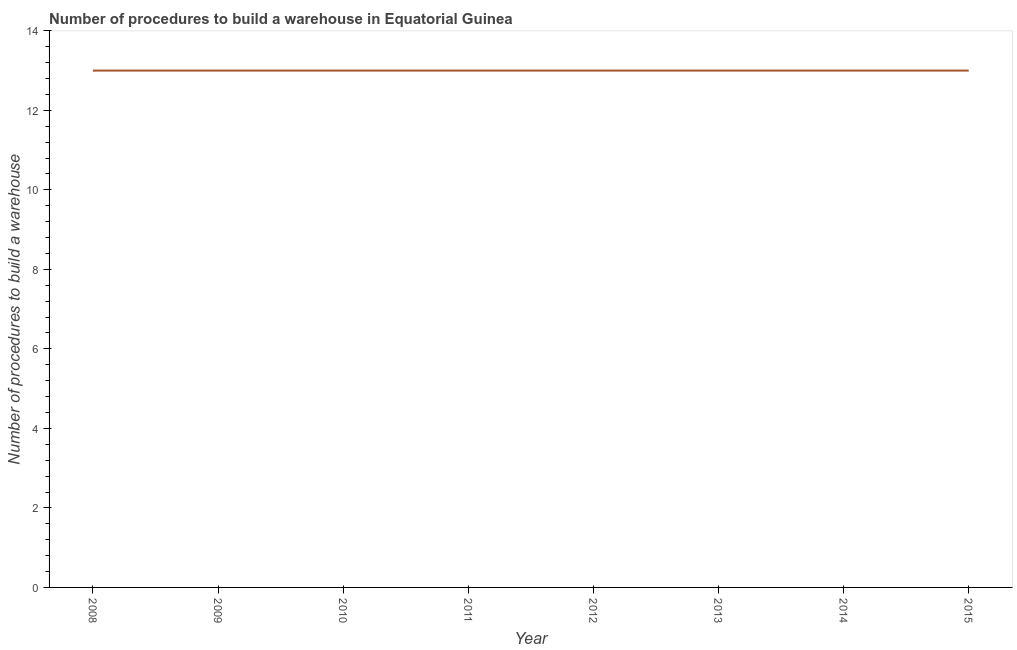What is the number of procedures to build a warehouse in 2010?
Offer a very short reply. 13. Across all years, what is the maximum number of procedures to build a warehouse?
Keep it short and to the point. 13. Across all years, what is the minimum number of procedures to build a warehouse?
Give a very brief answer. 13. What is the sum of the number of procedures to build a warehouse?
Offer a terse response. 104. What is the difference between the number of procedures to build a warehouse in 2010 and 2012?
Keep it short and to the point. 0. What is the average number of procedures to build a warehouse per year?
Offer a very short reply. 13. In how many years, is the number of procedures to build a warehouse greater than 2 ?
Provide a short and direct response. 8. Do a majority of the years between 2015 and 2014 (inclusive) have number of procedures to build a warehouse greater than 1.2000000000000002 ?
Ensure brevity in your answer.  No. Is the number of procedures to build a warehouse in 2010 less than that in 2012?
Offer a terse response. No. Is the difference between the number of procedures to build a warehouse in 2013 and 2015 greater than the difference between any two years?
Keep it short and to the point. Yes. Does the number of procedures to build a warehouse monotonically increase over the years?
Ensure brevity in your answer.  No. How many years are there in the graph?
Offer a very short reply. 8. What is the difference between two consecutive major ticks on the Y-axis?
Your answer should be compact. 2. Are the values on the major ticks of Y-axis written in scientific E-notation?
Make the answer very short. No. Does the graph contain grids?
Your answer should be compact. No. What is the title of the graph?
Your answer should be compact. Number of procedures to build a warehouse in Equatorial Guinea. What is the label or title of the Y-axis?
Provide a short and direct response. Number of procedures to build a warehouse. What is the Number of procedures to build a warehouse of 2008?
Provide a short and direct response. 13. What is the Number of procedures to build a warehouse in 2011?
Make the answer very short. 13. What is the Number of procedures to build a warehouse of 2012?
Your response must be concise. 13. What is the Number of procedures to build a warehouse in 2015?
Keep it short and to the point. 13. What is the difference between the Number of procedures to build a warehouse in 2008 and 2009?
Ensure brevity in your answer.  0. What is the difference between the Number of procedures to build a warehouse in 2008 and 2010?
Your answer should be very brief. 0. What is the difference between the Number of procedures to build a warehouse in 2008 and 2012?
Provide a succinct answer. 0. What is the difference between the Number of procedures to build a warehouse in 2008 and 2013?
Provide a succinct answer. 0. What is the difference between the Number of procedures to build a warehouse in 2008 and 2015?
Your answer should be very brief. 0. What is the difference between the Number of procedures to build a warehouse in 2009 and 2011?
Ensure brevity in your answer.  0. What is the difference between the Number of procedures to build a warehouse in 2009 and 2013?
Provide a short and direct response. 0. What is the difference between the Number of procedures to build a warehouse in 2009 and 2014?
Keep it short and to the point. 0. What is the difference between the Number of procedures to build a warehouse in 2010 and 2011?
Provide a short and direct response. 0. What is the difference between the Number of procedures to build a warehouse in 2010 and 2012?
Give a very brief answer. 0. What is the difference between the Number of procedures to build a warehouse in 2010 and 2013?
Your answer should be very brief. 0. What is the difference between the Number of procedures to build a warehouse in 2010 and 2014?
Give a very brief answer. 0. What is the difference between the Number of procedures to build a warehouse in 2010 and 2015?
Make the answer very short. 0. What is the difference between the Number of procedures to build a warehouse in 2011 and 2013?
Ensure brevity in your answer.  0. What is the difference between the Number of procedures to build a warehouse in 2012 and 2013?
Your answer should be very brief. 0. What is the ratio of the Number of procedures to build a warehouse in 2008 to that in 2011?
Your answer should be compact. 1. What is the ratio of the Number of procedures to build a warehouse in 2008 to that in 2013?
Ensure brevity in your answer.  1. What is the ratio of the Number of procedures to build a warehouse in 2008 to that in 2015?
Give a very brief answer. 1. What is the ratio of the Number of procedures to build a warehouse in 2009 to that in 2011?
Give a very brief answer. 1. What is the ratio of the Number of procedures to build a warehouse in 2009 to that in 2013?
Make the answer very short. 1. What is the ratio of the Number of procedures to build a warehouse in 2009 to that in 2014?
Provide a short and direct response. 1. What is the ratio of the Number of procedures to build a warehouse in 2010 to that in 2012?
Your answer should be very brief. 1. What is the ratio of the Number of procedures to build a warehouse in 2010 to that in 2013?
Your answer should be compact. 1. What is the ratio of the Number of procedures to build a warehouse in 2011 to that in 2014?
Offer a terse response. 1. What is the ratio of the Number of procedures to build a warehouse in 2011 to that in 2015?
Your answer should be very brief. 1. What is the ratio of the Number of procedures to build a warehouse in 2013 to that in 2014?
Keep it short and to the point. 1. What is the ratio of the Number of procedures to build a warehouse in 2014 to that in 2015?
Offer a terse response. 1. 